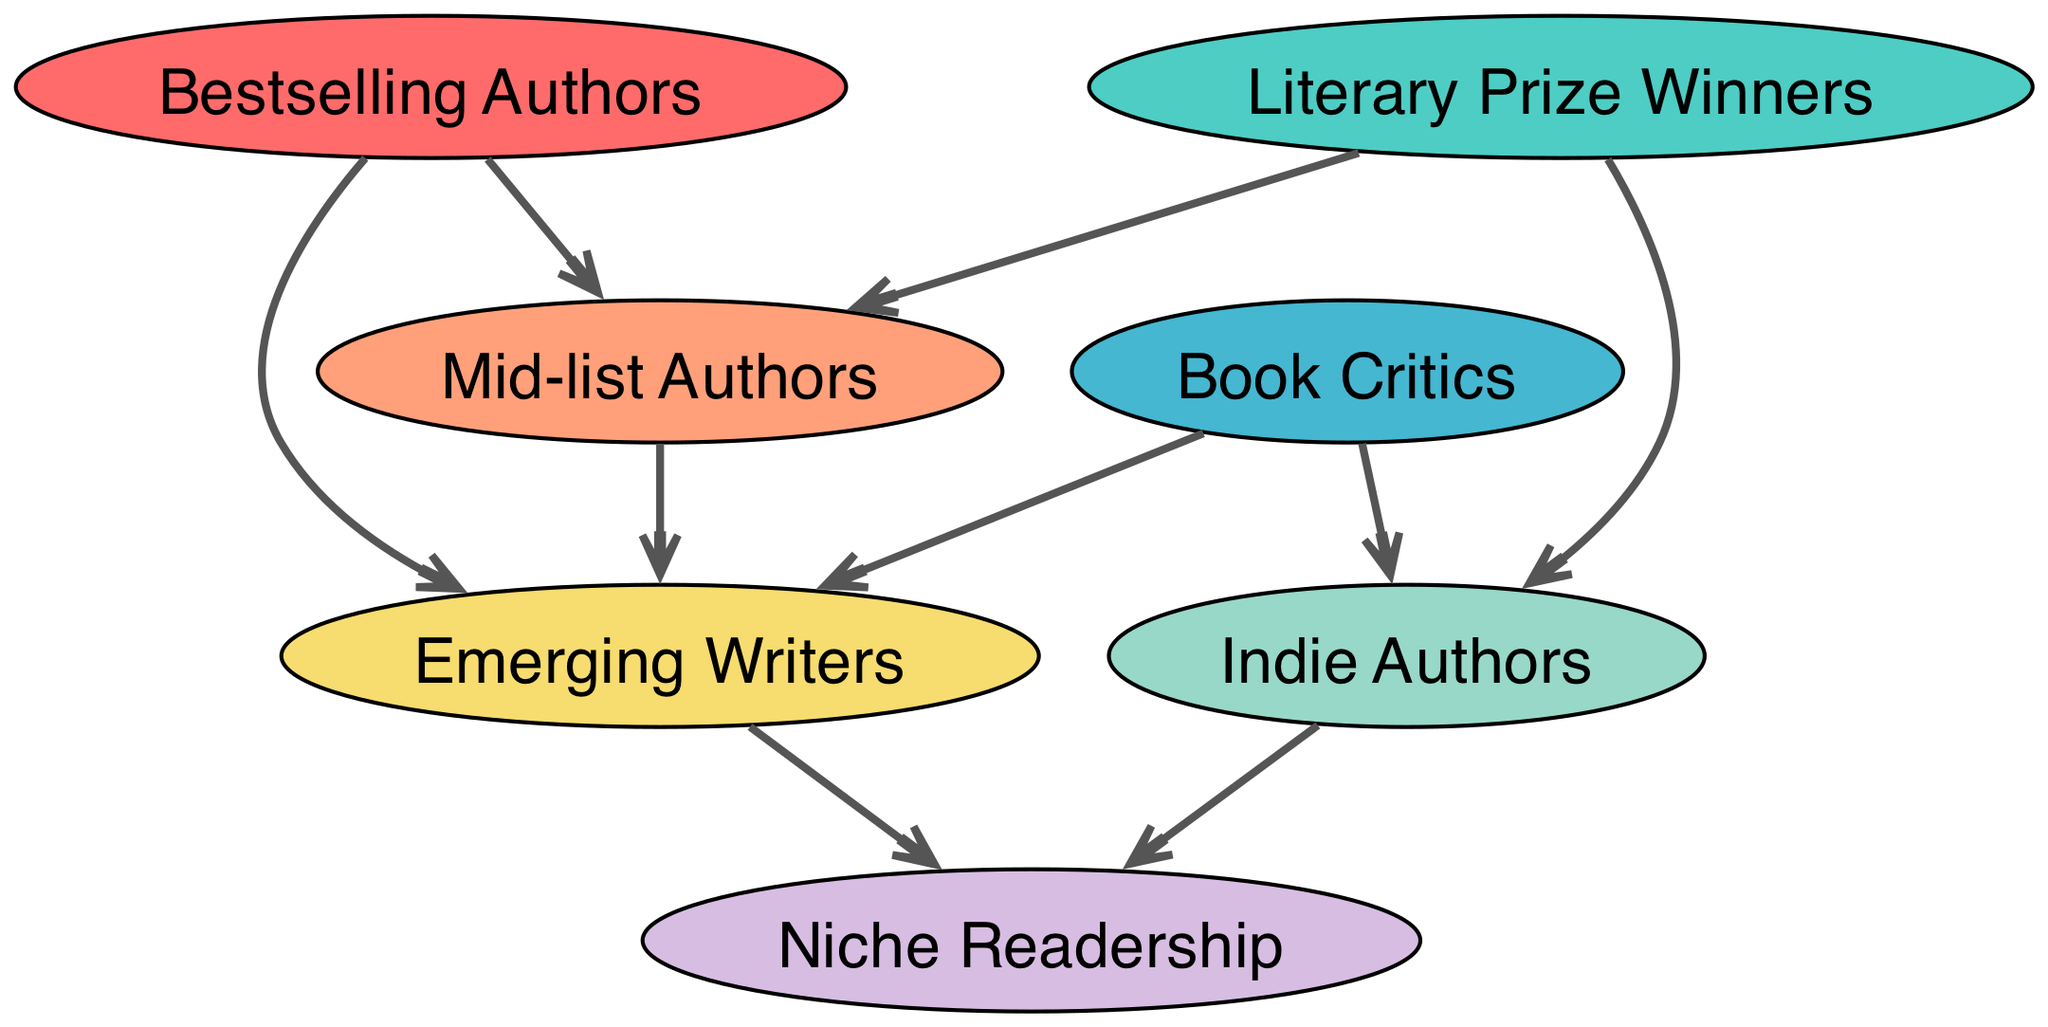What are the two main categories of authors that prey on Emerging Writers? The diagram indicates that Bestselling Authors and Mid-list Authors both prey on Emerging Writers, as shown by the directed edges leading from those nodes to the Emerging Writers node.
Answer: Bestselling Authors, Mid-list Authors Which author type preys exclusively on Niche Readership? The diagram shows that both Indie Authors and Emerging Writers have directed edges leading to Niche Readership, indicating that they rely on this specific audience. However, only Indie Authors have a direct connection to Niche Readership without other prey relationships shown.
Answer: Indie Authors How many author types prey on Mid-list Authors? From the diagram, Literary Prize Winners are identified as the sole author type that preys on Mid-list Authors, as indicated by a single directed edge leading from Literary Prize Winners to Mid-list Authors.
Answer: One Who is the top predator of Indie Authors in the diagram? The diagram highlights that both Literary Prize Winners and Book Critics prey on Indie Authors. To determine the top predator, we look at the origins of the arrows; Literary Prize Winners are at a higher level in the hierarchy than Book Critics, indicating they are the primary predator.
Answer: Literary Prize Winners Which category has no predators according to the diagram? The Niche Readership node shows no edges pointing to it, indicating it does not get preyed upon by any other author types mentioned in the diagram. This makes it unique in the food chain.
Answer: Niche Readership How many edges lead from Emerging Writers to other author types? In the diagram, Emerging Writers are shown to be preyed upon by Mid-list Authors, Book Critics, and both Indie Authors and Bestselling Authors; this gives a total of three directed edges leading away from the Emerging Writers node.
Answer: Three What relationship exists between Book Critics and Emerging Writers? The diagram exhibits that Book Critics prey on Emerging Writers, signified by a directed edge from Book Critics to Emerging Writers, establishing a predator-prey relationship.
Answer: Prey Which type of authors have the widest array of predators in this diagram? The Mid-list Authors node has a more complex relationship, being predated upon by Literary Prize Winners and influencing Emerging Writers. This layering of relationships shows that Mid-list Authors have a variety of connections with other author types, highlighting their position in the literary food chain.
Answer: Mid-list Authors 